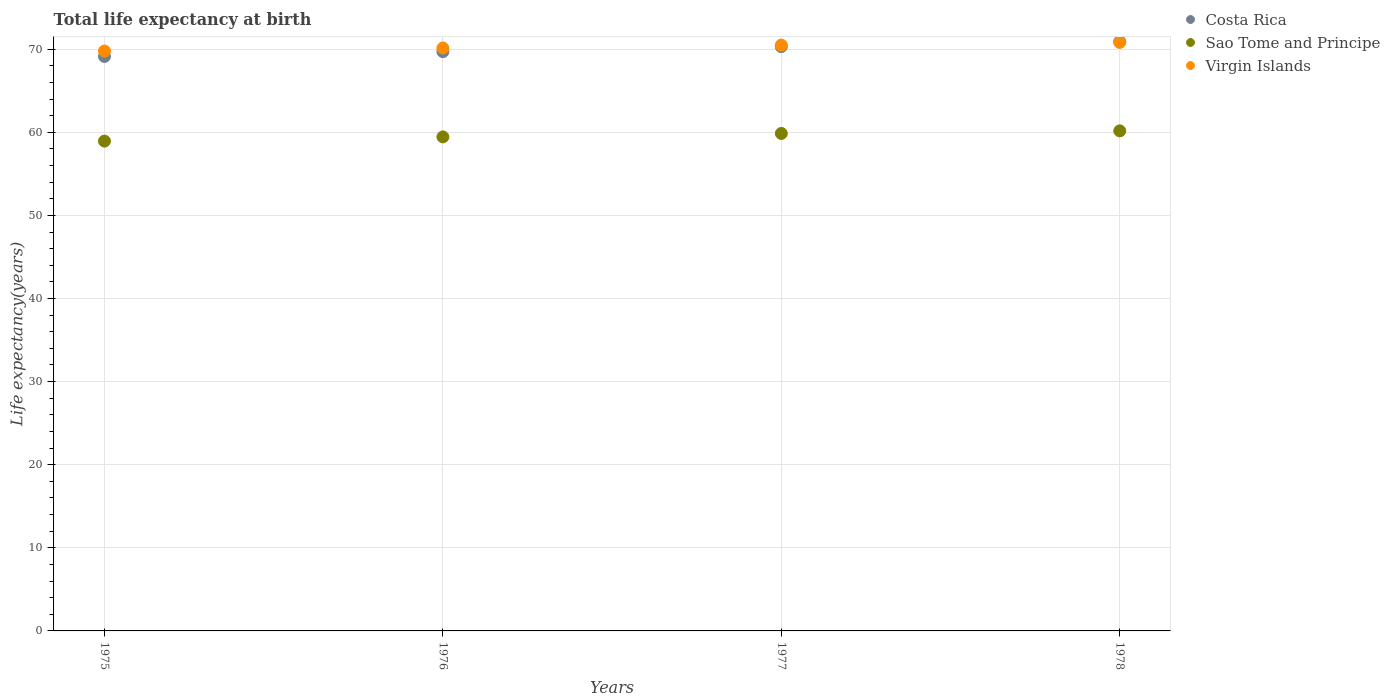What is the life expectancy at birth in in Virgin Islands in 1976?
Offer a very short reply. 70.14. Across all years, what is the maximum life expectancy at birth in in Costa Rica?
Provide a short and direct response. 70.92. Across all years, what is the minimum life expectancy at birth in in Sao Tome and Principe?
Your answer should be compact. 58.94. In which year was the life expectancy at birth in in Costa Rica maximum?
Your answer should be very brief. 1978. In which year was the life expectancy at birth in in Costa Rica minimum?
Your response must be concise. 1975. What is the total life expectancy at birth in in Costa Rica in the graph?
Provide a short and direct response. 280.05. What is the difference between the life expectancy at birth in in Sao Tome and Principe in 1975 and that in 1978?
Offer a very short reply. -1.23. What is the difference between the life expectancy at birth in in Sao Tome and Principe in 1976 and the life expectancy at birth in in Virgin Islands in 1977?
Offer a very short reply. -11.04. What is the average life expectancy at birth in in Virgin Islands per year?
Provide a succinct answer. 70.31. In the year 1976, what is the difference between the life expectancy at birth in in Sao Tome and Principe and life expectancy at birth in in Virgin Islands?
Offer a terse response. -10.7. In how many years, is the life expectancy at birth in in Sao Tome and Principe greater than 36 years?
Make the answer very short. 4. What is the ratio of the life expectancy at birth in in Costa Rica in 1975 to that in 1977?
Make the answer very short. 0.98. Is the difference between the life expectancy at birth in in Sao Tome and Principe in 1976 and 1978 greater than the difference between the life expectancy at birth in in Virgin Islands in 1976 and 1978?
Keep it short and to the point. No. What is the difference between the highest and the second highest life expectancy at birth in in Virgin Islands?
Provide a short and direct response. 0.33. What is the difference between the highest and the lowest life expectancy at birth in in Costa Rica?
Offer a very short reply. 1.8. In how many years, is the life expectancy at birth in in Costa Rica greater than the average life expectancy at birth in in Costa Rica taken over all years?
Keep it short and to the point. 2. Is it the case that in every year, the sum of the life expectancy at birth in in Sao Tome and Principe and life expectancy at birth in in Costa Rica  is greater than the life expectancy at birth in in Virgin Islands?
Provide a short and direct response. Yes. Is the life expectancy at birth in in Virgin Islands strictly greater than the life expectancy at birth in in Sao Tome and Principe over the years?
Offer a terse response. Yes. How many dotlines are there?
Your response must be concise. 3. Does the graph contain grids?
Ensure brevity in your answer.  Yes. How many legend labels are there?
Your answer should be compact. 3. What is the title of the graph?
Your answer should be compact. Total life expectancy at birth. What is the label or title of the Y-axis?
Give a very brief answer. Life expectancy(years). What is the Life expectancy(years) of Costa Rica in 1975?
Offer a terse response. 69.12. What is the Life expectancy(years) of Sao Tome and Principe in 1975?
Provide a succinct answer. 58.94. What is the Life expectancy(years) of Virgin Islands in 1975?
Provide a short and direct response. 69.78. What is the Life expectancy(years) of Costa Rica in 1976?
Provide a succinct answer. 69.7. What is the Life expectancy(years) in Sao Tome and Principe in 1976?
Provide a succinct answer. 59.45. What is the Life expectancy(years) in Virgin Islands in 1976?
Your answer should be compact. 70.14. What is the Life expectancy(years) of Costa Rica in 1977?
Give a very brief answer. 70.31. What is the Life expectancy(years) of Sao Tome and Principe in 1977?
Provide a succinct answer. 59.86. What is the Life expectancy(years) of Virgin Islands in 1977?
Provide a succinct answer. 70.49. What is the Life expectancy(years) of Costa Rica in 1978?
Offer a terse response. 70.92. What is the Life expectancy(years) in Sao Tome and Principe in 1978?
Your answer should be very brief. 60.17. What is the Life expectancy(years) in Virgin Islands in 1978?
Your answer should be very brief. 70.82. Across all years, what is the maximum Life expectancy(years) of Costa Rica?
Make the answer very short. 70.92. Across all years, what is the maximum Life expectancy(years) in Sao Tome and Principe?
Your answer should be very brief. 60.17. Across all years, what is the maximum Life expectancy(years) in Virgin Islands?
Ensure brevity in your answer.  70.82. Across all years, what is the minimum Life expectancy(years) of Costa Rica?
Give a very brief answer. 69.12. Across all years, what is the minimum Life expectancy(years) in Sao Tome and Principe?
Make the answer very short. 58.94. Across all years, what is the minimum Life expectancy(years) of Virgin Islands?
Offer a very short reply. 69.78. What is the total Life expectancy(years) of Costa Rica in the graph?
Make the answer very short. 280.05. What is the total Life expectancy(years) of Sao Tome and Principe in the graph?
Your answer should be very brief. 238.42. What is the total Life expectancy(years) of Virgin Islands in the graph?
Your answer should be very brief. 281.23. What is the difference between the Life expectancy(years) of Costa Rica in 1975 and that in 1976?
Keep it short and to the point. -0.58. What is the difference between the Life expectancy(years) of Sao Tome and Principe in 1975 and that in 1976?
Offer a very short reply. -0.51. What is the difference between the Life expectancy(years) in Virgin Islands in 1975 and that in 1976?
Offer a terse response. -0.37. What is the difference between the Life expectancy(years) in Costa Rica in 1975 and that in 1977?
Your response must be concise. -1.19. What is the difference between the Life expectancy(years) of Sao Tome and Principe in 1975 and that in 1977?
Provide a succinct answer. -0.92. What is the difference between the Life expectancy(years) of Virgin Islands in 1975 and that in 1977?
Make the answer very short. -0.71. What is the difference between the Life expectancy(years) in Costa Rica in 1975 and that in 1978?
Keep it short and to the point. -1.8. What is the difference between the Life expectancy(years) in Sao Tome and Principe in 1975 and that in 1978?
Provide a short and direct response. -1.23. What is the difference between the Life expectancy(years) of Virgin Islands in 1975 and that in 1978?
Make the answer very short. -1.04. What is the difference between the Life expectancy(years) in Costa Rica in 1976 and that in 1977?
Your answer should be very brief. -0.6. What is the difference between the Life expectancy(years) in Sao Tome and Principe in 1976 and that in 1977?
Ensure brevity in your answer.  -0.41. What is the difference between the Life expectancy(years) of Virgin Islands in 1976 and that in 1977?
Give a very brief answer. -0.35. What is the difference between the Life expectancy(years) in Costa Rica in 1976 and that in 1978?
Make the answer very short. -1.22. What is the difference between the Life expectancy(years) of Sao Tome and Principe in 1976 and that in 1978?
Provide a short and direct response. -0.72. What is the difference between the Life expectancy(years) of Virgin Islands in 1976 and that in 1978?
Provide a succinct answer. -0.67. What is the difference between the Life expectancy(years) of Costa Rica in 1977 and that in 1978?
Your answer should be very brief. -0.61. What is the difference between the Life expectancy(years) in Sao Tome and Principe in 1977 and that in 1978?
Make the answer very short. -0.31. What is the difference between the Life expectancy(years) in Virgin Islands in 1977 and that in 1978?
Ensure brevity in your answer.  -0.33. What is the difference between the Life expectancy(years) in Costa Rica in 1975 and the Life expectancy(years) in Sao Tome and Principe in 1976?
Provide a short and direct response. 9.67. What is the difference between the Life expectancy(years) in Costa Rica in 1975 and the Life expectancy(years) in Virgin Islands in 1976?
Your response must be concise. -1.03. What is the difference between the Life expectancy(years) in Sao Tome and Principe in 1975 and the Life expectancy(years) in Virgin Islands in 1976?
Offer a very short reply. -11.2. What is the difference between the Life expectancy(years) of Costa Rica in 1975 and the Life expectancy(years) of Sao Tome and Principe in 1977?
Give a very brief answer. 9.26. What is the difference between the Life expectancy(years) in Costa Rica in 1975 and the Life expectancy(years) in Virgin Islands in 1977?
Provide a short and direct response. -1.37. What is the difference between the Life expectancy(years) in Sao Tome and Principe in 1975 and the Life expectancy(years) in Virgin Islands in 1977?
Offer a terse response. -11.55. What is the difference between the Life expectancy(years) in Costa Rica in 1975 and the Life expectancy(years) in Sao Tome and Principe in 1978?
Keep it short and to the point. 8.95. What is the difference between the Life expectancy(years) of Costa Rica in 1975 and the Life expectancy(years) of Virgin Islands in 1978?
Provide a short and direct response. -1.7. What is the difference between the Life expectancy(years) in Sao Tome and Principe in 1975 and the Life expectancy(years) in Virgin Islands in 1978?
Give a very brief answer. -11.88. What is the difference between the Life expectancy(years) in Costa Rica in 1976 and the Life expectancy(years) in Sao Tome and Principe in 1977?
Keep it short and to the point. 9.84. What is the difference between the Life expectancy(years) in Costa Rica in 1976 and the Life expectancy(years) in Virgin Islands in 1977?
Your answer should be compact. -0.79. What is the difference between the Life expectancy(years) of Sao Tome and Principe in 1976 and the Life expectancy(years) of Virgin Islands in 1977?
Your response must be concise. -11.04. What is the difference between the Life expectancy(years) in Costa Rica in 1976 and the Life expectancy(years) in Sao Tome and Principe in 1978?
Provide a short and direct response. 9.53. What is the difference between the Life expectancy(years) in Costa Rica in 1976 and the Life expectancy(years) in Virgin Islands in 1978?
Provide a short and direct response. -1.11. What is the difference between the Life expectancy(years) of Sao Tome and Principe in 1976 and the Life expectancy(years) of Virgin Islands in 1978?
Your response must be concise. -11.37. What is the difference between the Life expectancy(years) of Costa Rica in 1977 and the Life expectancy(years) of Sao Tome and Principe in 1978?
Provide a succinct answer. 10.13. What is the difference between the Life expectancy(years) in Costa Rica in 1977 and the Life expectancy(years) in Virgin Islands in 1978?
Ensure brevity in your answer.  -0.51. What is the difference between the Life expectancy(years) in Sao Tome and Principe in 1977 and the Life expectancy(years) in Virgin Islands in 1978?
Your answer should be very brief. -10.96. What is the average Life expectancy(years) of Costa Rica per year?
Keep it short and to the point. 70.01. What is the average Life expectancy(years) in Sao Tome and Principe per year?
Your answer should be compact. 59.6. What is the average Life expectancy(years) in Virgin Islands per year?
Your answer should be very brief. 70.31. In the year 1975, what is the difference between the Life expectancy(years) of Costa Rica and Life expectancy(years) of Sao Tome and Principe?
Offer a very short reply. 10.18. In the year 1975, what is the difference between the Life expectancy(years) in Costa Rica and Life expectancy(years) in Virgin Islands?
Make the answer very short. -0.66. In the year 1975, what is the difference between the Life expectancy(years) in Sao Tome and Principe and Life expectancy(years) in Virgin Islands?
Offer a terse response. -10.84. In the year 1976, what is the difference between the Life expectancy(years) of Costa Rica and Life expectancy(years) of Sao Tome and Principe?
Keep it short and to the point. 10.26. In the year 1976, what is the difference between the Life expectancy(years) of Costa Rica and Life expectancy(years) of Virgin Islands?
Ensure brevity in your answer.  -0.44. In the year 1976, what is the difference between the Life expectancy(years) of Sao Tome and Principe and Life expectancy(years) of Virgin Islands?
Your answer should be compact. -10.7. In the year 1977, what is the difference between the Life expectancy(years) in Costa Rica and Life expectancy(years) in Sao Tome and Principe?
Your response must be concise. 10.45. In the year 1977, what is the difference between the Life expectancy(years) in Costa Rica and Life expectancy(years) in Virgin Islands?
Offer a very short reply. -0.18. In the year 1977, what is the difference between the Life expectancy(years) in Sao Tome and Principe and Life expectancy(years) in Virgin Islands?
Offer a very short reply. -10.63. In the year 1978, what is the difference between the Life expectancy(years) in Costa Rica and Life expectancy(years) in Sao Tome and Principe?
Make the answer very short. 10.75. In the year 1978, what is the difference between the Life expectancy(years) of Costa Rica and Life expectancy(years) of Virgin Islands?
Your response must be concise. 0.1. In the year 1978, what is the difference between the Life expectancy(years) in Sao Tome and Principe and Life expectancy(years) in Virgin Islands?
Give a very brief answer. -10.65. What is the ratio of the Life expectancy(years) of Sao Tome and Principe in 1975 to that in 1976?
Offer a very short reply. 0.99. What is the ratio of the Life expectancy(years) in Costa Rica in 1975 to that in 1977?
Your response must be concise. 0.98. What is the ratio of the Life expectancy(years) of Sao Tome and Principe in 1975 to that in 1977?
Give a very brief answer. 0.98. What is the ratio of the Life expectancy(years) of Virgin Islands in 1975 to that in 1977?
Your response must be concise. 0.99. What is the ratio of the Life expectancy(years) in Costa Rica in 1975 to that in 1978?
Your answer should be very brief. 0.97. What is the ratio of the Life expectancy(years) of Sao Tome and Principe in 1975 to that in 1978?
Your response must be concise. 0.98. What is the ratio of the Life expectancy(years) in Sao Tome and Principe in 1976 to that in 1977?
Give a very brief answer. 0.99. What is the ratio of the Life expectancy(years) in Virgin Islands in 1976 to that in 1977?
Give a very brief answer. 1. What is the ratio of the Life expectancy(years) in Costa Rica in 1976 to that in 1978?
Provide a short and direct response. 0.98. What is the ratio of the Life expectancy(years) of Costa Rica in 1977 to that in 1978?
Offer a terse response. 0.99. What is the ratio of the Life expectancy(years) in Sao Tome and Principe in 1977 to that in 1978?
Your answer should be very brief. 0.99. What is the ratio of the Life expectancy(years) of Virgin Islands in 1977 to that in 1978?
Your answer should be very brief. 1. What is the difference between the highest and the second highest Life expectancy(years) of Costa Rica?
Your answer should be very brief. 0.61. What is the difference between the highest and the second highest Life expectancy(years) of Sao Tome and Principe?
Ensure brevity in your answer.  0.31. What is the difference between the highest and the second highest Life expectancy(years) of Virgin Islands?
Give a very brief answer. 0.33. What is the difference between the highest and the lowest Life expectancy(years) of Costa Rica?
Your response must be concise. 1.8. What is the difference between the highest and the lowest Life expectancy(years) of Sao Tome and Principe?
Your answer should be compact. 1.23. What is the difference between the highest and the lowest Life expectancy(years) of Virgin Islands?
Your answer should be very brief. 1.04. 